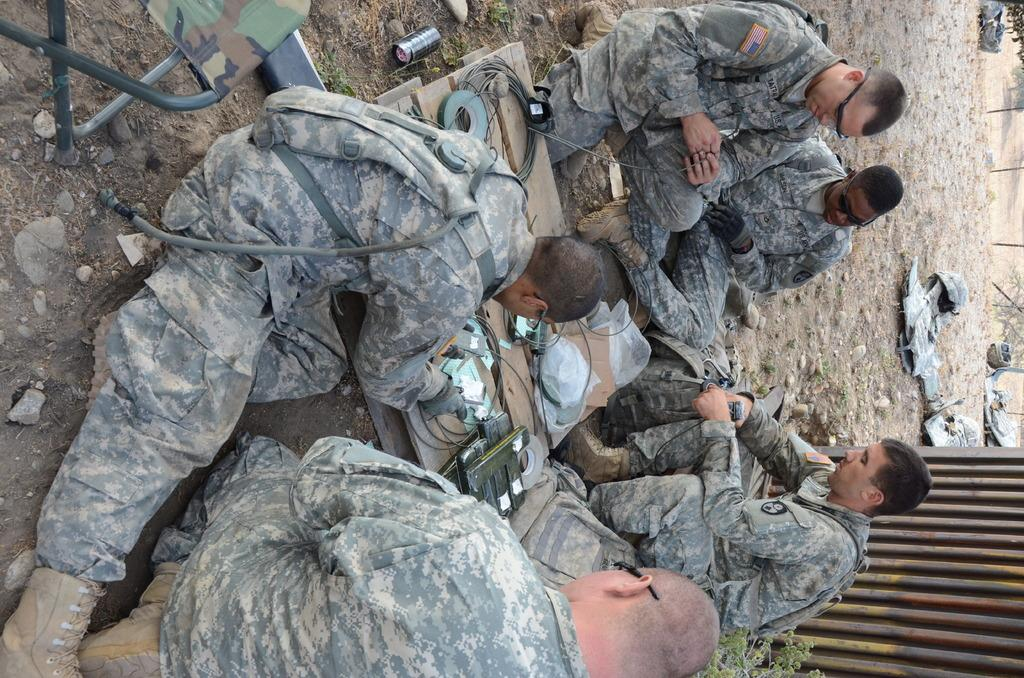How many people are in the image? There are people in the image, but the exact number is not specified. What is placed in front of the people? There are plastic covers in front of the people. What is the wooden plank used for in the image? Cables are present on a wooden plank, suggesting it might be used for cable management. What can be seen in the background of the image? There are trees in the background of the image. How many bikes are parked next to the people in the image? There is no mention of bikes in the image, so we cannot determine how many there might be. What is the thumb doing in the image? There is no thumb present in the image, so we cannot describe its actions. 